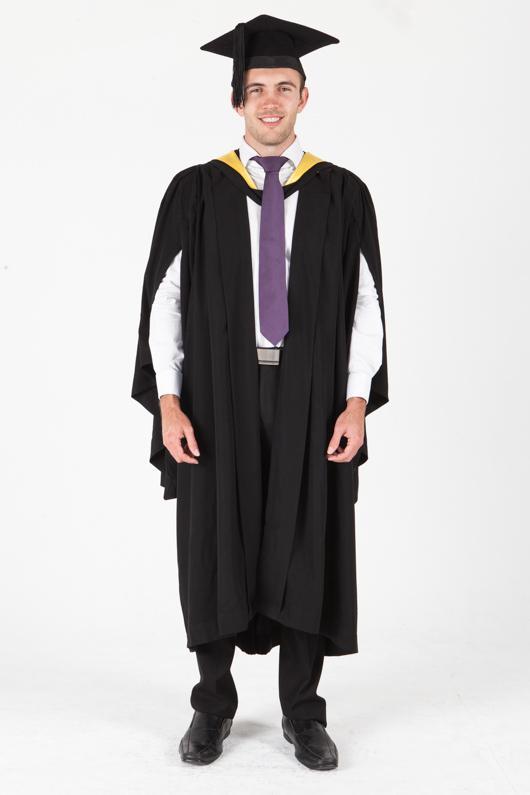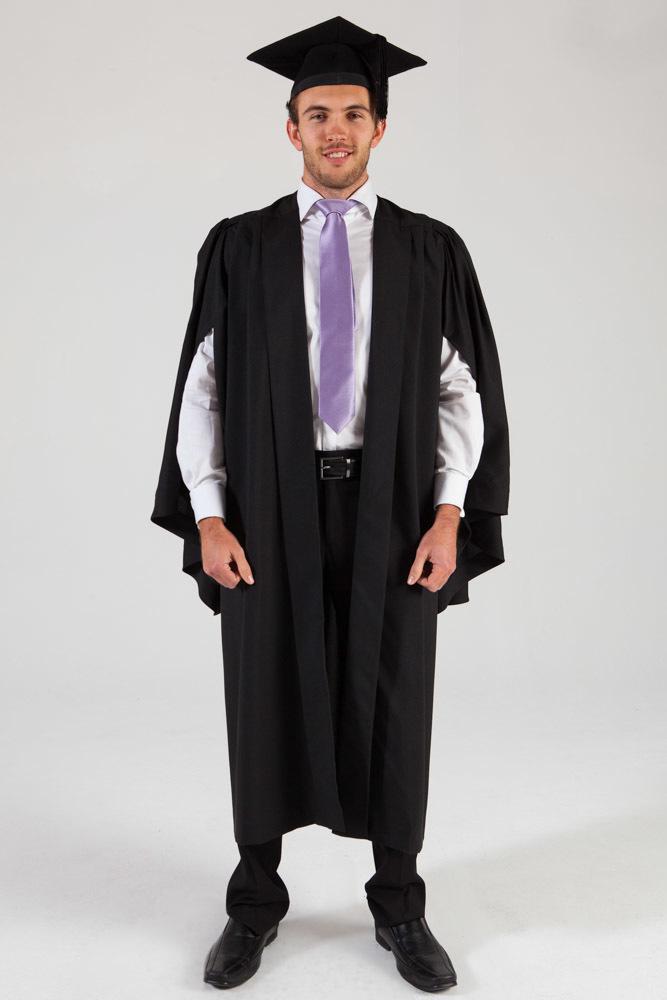The first image is the image on the left, the second image is the image on the right. Examine the images to the left and right. Is the description "An image shows a male graduate wearing something yellow around his neck." accurate? Answer yes or no. Yes. The first image is the image on the left, the second image is the image on the right. Given the left and right images, does the statement "In both images a man wearing a black cap and gown and purple tie is standing facing forward with his arms at his sides." hold true? Answer yes or no. Yes. 